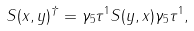Convert formula to latex. <formula><loc_0><loc_0><loc_500><loc_500>S ( x , y ) ^ { \dagger } = \gamma _ { 5 } \tau ^ { 1 } S ( y , x ) \gamma _ { 5 } \tau ^ { 1 } ,</formula> 